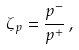Convert formula to latex. <formula><loc_0><loc_0><loc_500><loc_500>\zeta _ { p } = \frac { p ^ { - } } { p ^ { + } } \, ,</formula> 